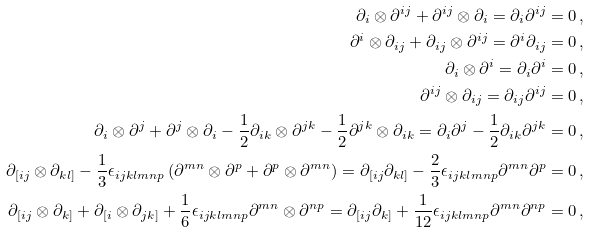<formula> <loc_0><loc_0><loc_500><loc_500>\partial _ { i } \otimes \partial ^ { i j } + \partial ^ { i j } \otimes \partial _ { i } = \partial _ { i } \partial ^ { i j } & = 0 \, , \\ \partial ^ { i } \otimes \partial _ { i j } + \partial _ { i j } \otimes \partial ^ { i j } = \partial ^ { i } \partial _ { i j } & = 0 \, , \\ \partial _ { i } \otimes \partial ^ { i } = \partial _ { i } \partial ^ { i } & = 0 \, , \\ \partial ^ { i j } \otimes \partial _ { i j } = \partial _ { i j } \partial ^ { i j } & = 0 \, , \\ \partial _ { i } \otimes \partial ^ { j } + \partial ^ { j } \otimes \partial _ { i } - \frac { 1 } { 2 } \partial _ { i k } \otimes \partial ^ { j k } - \frac { 1 } { 2 } \partial ^ { j k } \otimes \partial _ { i k } = \partial _ { i } \partial ^ { j } - \frac { 1 } { 2 } \partial _ { i k } \partial ^ { j k } & = 0 \, , \\ \partial _ { [ i j } \otimes \partial _ { k l ] } - \frac { 1 } { 3 } \epsilon _ { i j k l m n p } \left ( \partial ^ { m n } \otimes \partial ^ { p } + \partial ^ { p } \otimes \partial ^ { m n } \right ) = \partial _ { [ i j } \partial _ { k l ] } - \frac { 2 } { 3 } \epsilon _ { i j k l m n p } \partial ^ { m n } \partial ^ { p } & = 0 \, , \\ \partial _ { [ i j } \otimes \partial _ { k ] } + \partial _ { [ i } \otimes \partial _ { j k ] } + \frac { 1 } { 6 } \epsilon _ { i j k l m n p } \partial ^ { m n } \otimes \partial ^ { n p } = \partial _ { [ i j } \partial _ { k ] } + \frac { 1 } { 1 2 } \epsilon _ { i j k l m n p } \partial ^ { m n } \partial ^ { n p } & = 0 \, ,</formula> 